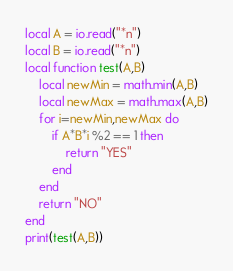<code> <loc_0><loc_0><loc_500><loc_500><_Lua_>local A = io.read("*n")
local B = io.read("*n")
local function test(A,B)
    local newMin = math.min(A,B)
    local newMax = math.max(A,B)
    for i=newMin,newMax do
        if A*B*i %2 == 1 then
            return "YES"
        end
    end
    return "NO"
end
print(test(A,B))</code> 